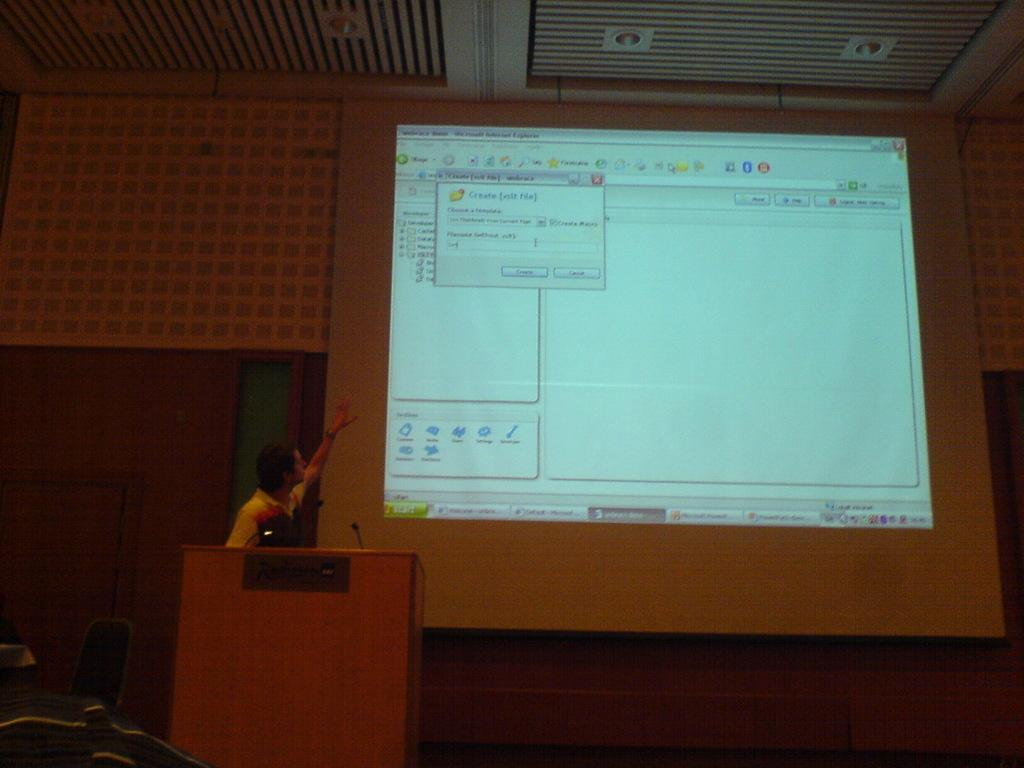<image>
Describe the image concisely. Create File is the header of the window shown on the computer screen. 